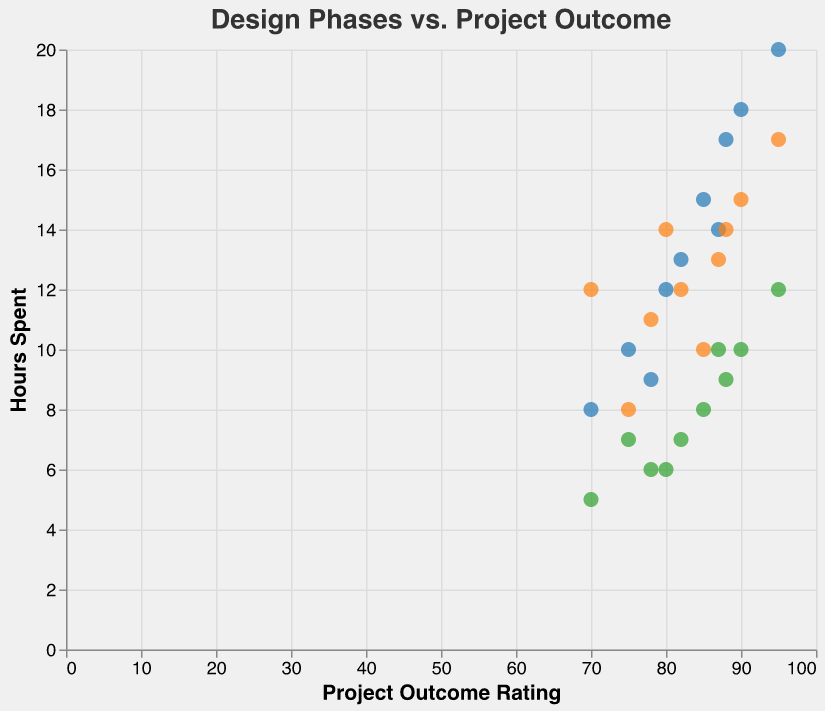What is the title of the plot? The title of the plot is displayed at the top within the plot area. It reads "Design Phases vs. Project Outcome."
Answer: Design Phases vs. Project Outcome What is the x-axis representing? The x-axis title is "Project Outcome Rating," indicating it represents the Project Outcome Rating values.
Answer: Project Outcome Rating What does the blue color represent in the plot? The legend or the description near the colors in the plot indicates that blue points represent "Research Hours."
Answer: Research Hours Which project has the highest Outcome Rating? By looking for the highest point on the x-axis, the project "Marketing Material" has the highest Outcome Rating of 95.
Answer: Marketing Material Which designer spent the most hours on Finalization? By locating the highest point for the green color, which represents Finalization Hours, we observe that "Frank Turner" spent 12 hours.
Answer: Frank Turner How many hours did Jill Casey spend on Concept Development, and what was the Outcome Rating? The tooltip for the orange point associated with Jill Casey will reveal her "Concept Development Hours" (13) and "Outcome Rating" (87).
Answer: 13, 87 How do Research Hours correlate to Outcome Rating generally? Observing the overall pattern of the blue points on the plot, we see that more Research Hours generally correlate to higher Outcome Ratings.
Answer: Positive Correlation Which project had the least amount of Research and what was its Outcome Rating? Looking for the lowest blue point, "Logo Design" had the least Research Hours (8) with an Outcome Rating of 70.
Answer: Logo Design, 70 What is the total time Emma Brown spent on all three phases for "Logo Design"? Summing the hours across Research (8), Concept Development (12), and Finalization (5) gives 8 + 12 + 5 = 25 hours.
Answer: 25 hours Is there a noticeable pattern in time spent on Concept Development and Outcome Ratings? By examining the orange points, we see that projects with moderate Concept Development Hours tend to have varying Outcome Ratings, implying no strong pattern.
Answer: No strong pattern 